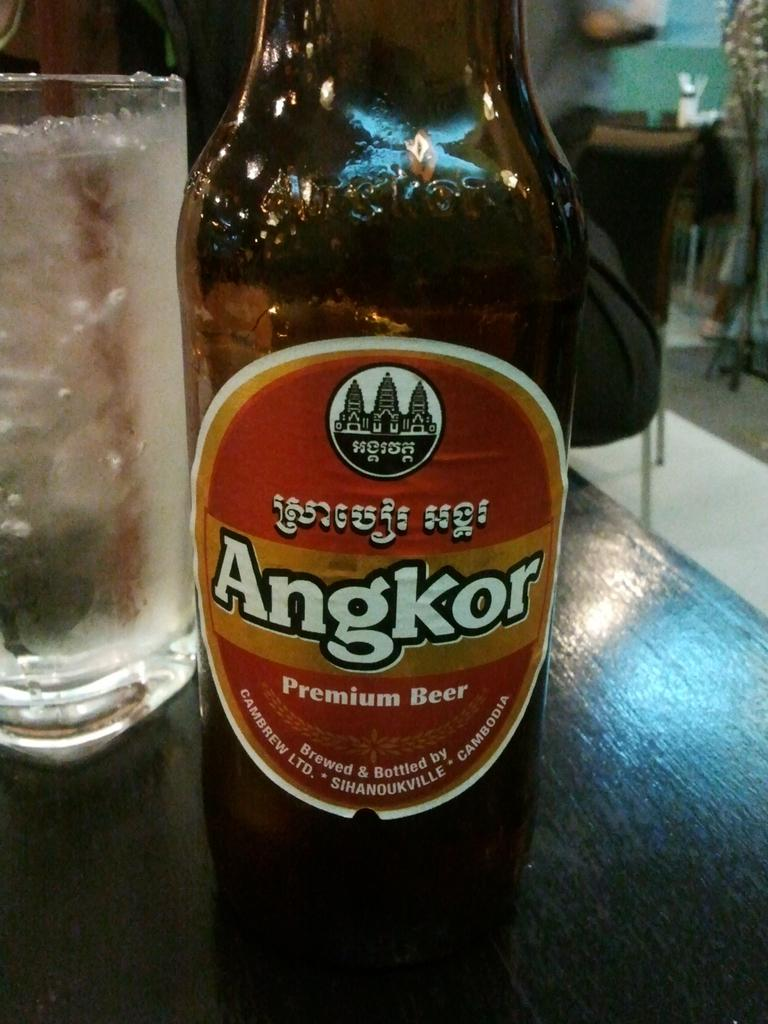<image>
Write a terse but informative summary of the picture. A bottle of Angkor beer setting on a table. 